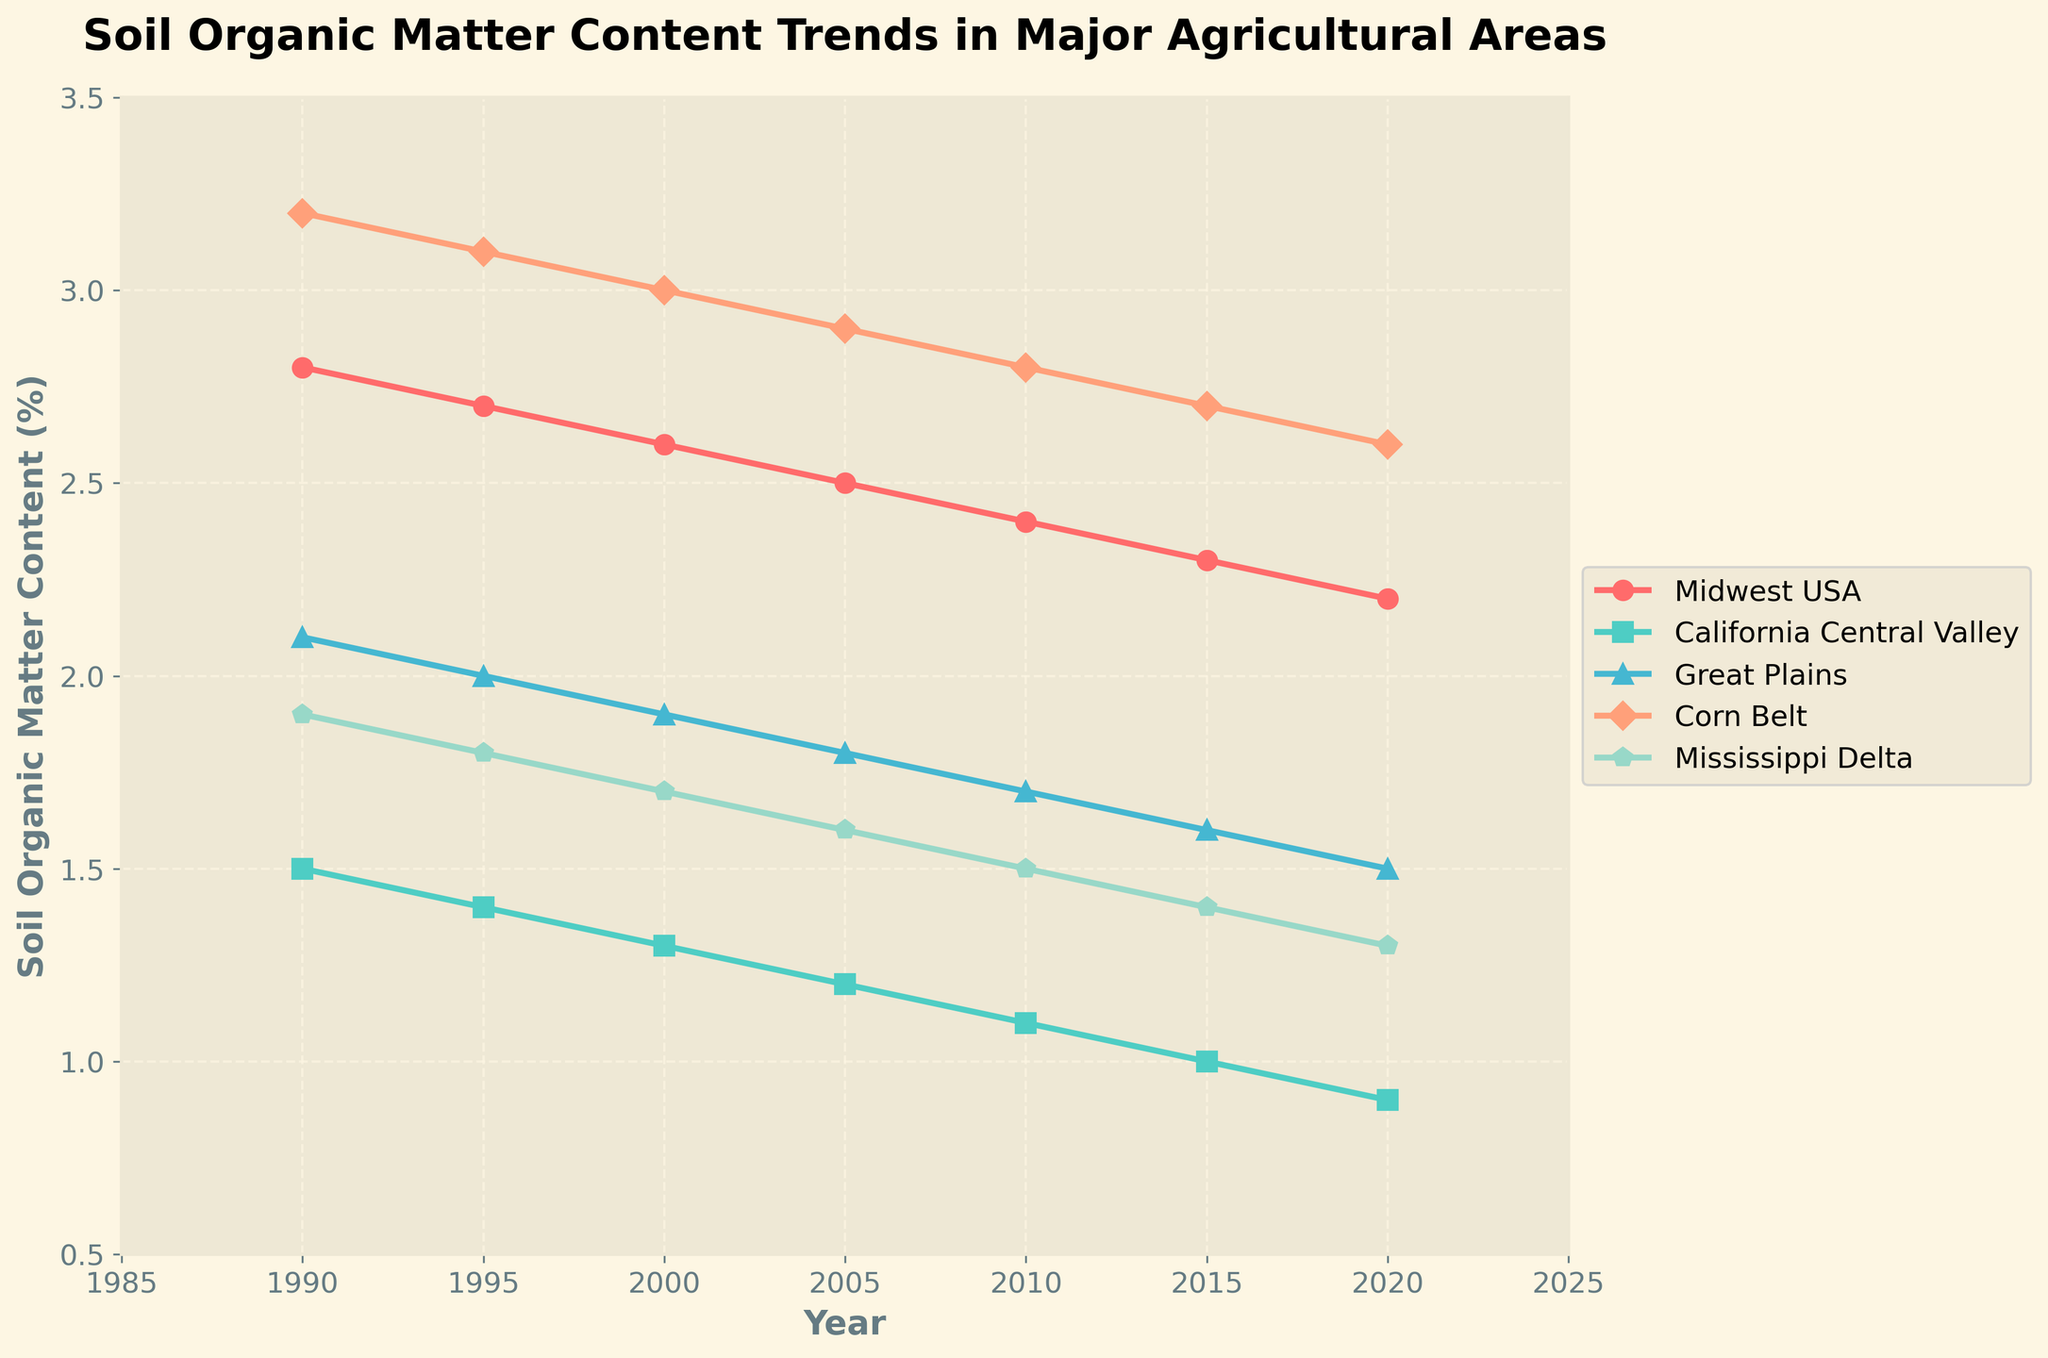What is the trend in soil organic matter content in the Corn Belt from 1990 to 2020? The line representing the Corn Belt shows a consistent decline from 3.2% in 1990 to 2.6% in 2020, with a decrement of 0.1 every five years.
Answer: Consistent decline Which two regions had the highest soil organic matter content in 1990 and 2020 respectively? In 1990, the Corn Belt had the highest soil organic matter content at 3.2%. By 2020, the Midwest USA had the highest content at 2.2%.
Answer: Corn Belt in 1990, Midwest USA in 2020 What was the average soil organic matter content for the Mississippi Delta over the entire period? Sum the soil organic matter content for Mississippi Delta from 1990 to 2020: (1.9 + 1.8 + 1.7 + 1.6 + 1.5 + 1.4 + 1.3) = 11.2, and then divide by 7 (number of data points): 11.2 / 7 = 1.6.
Answer: 1.6 Which region experienced the greatest decline in soil organic matter content over the 30 years, and by how much? Calculate the decline for each region by subtracting the 2020 value from the 1990 value. Midwest USA: 2.8 - 2.2 = 0.6, California Central Valley: 1.5 - 0.9 = 0.6, Great Plains: 2.1 - 1.5 = 0.6, Corn Belt: 3.2 - 2.6 = 0.6, Mississippi Delta: 1.9 - 1.3 = 0.6. Each region had a decline of 0.6.
Answer: All regions, 0.6 Which region had the lowest soil organic matter content in 2000, and what was the value? In 2000, the data points are: Midwest USA: 2.6, California Central Valley: 1.3, Great Plains: 1.9, Corn Belt: 3.0, Mississippi Delta: 1.7. The California Central Valley had the lowest at 1.3.
Answer: California Central Valley, 1.3 By how much did the soil organic matter content in the Great Plains drop between 1990 and 2010? Subtract the 2010 value from the 1990 value for the Great Plains: 2.1 - 1.7 = 0.4.
Answer: 0.4 In which year did California Central Valley and the Mississippi Delta have equal soil organic matter content? Compare the values year by year for California Central Valley and Mississippi Delta. In 2020, both had a value of 1.3.
Answer: 2020 What is the overall trend in soil organic matter content for all regions over the period from 1990 to 2020? All regions show a declining trend over the period from 1990 to 2020. Each region's content decreases steadily over time.
Answer: Declining trend Is the decline rate in each region similar or different? Provide a reasoning based on the figure. All regions have similar decline rates as they all dropped by 0.6 over the 30 years, indicating a uniform trend in reduction.
Answer: Similar decline rate 